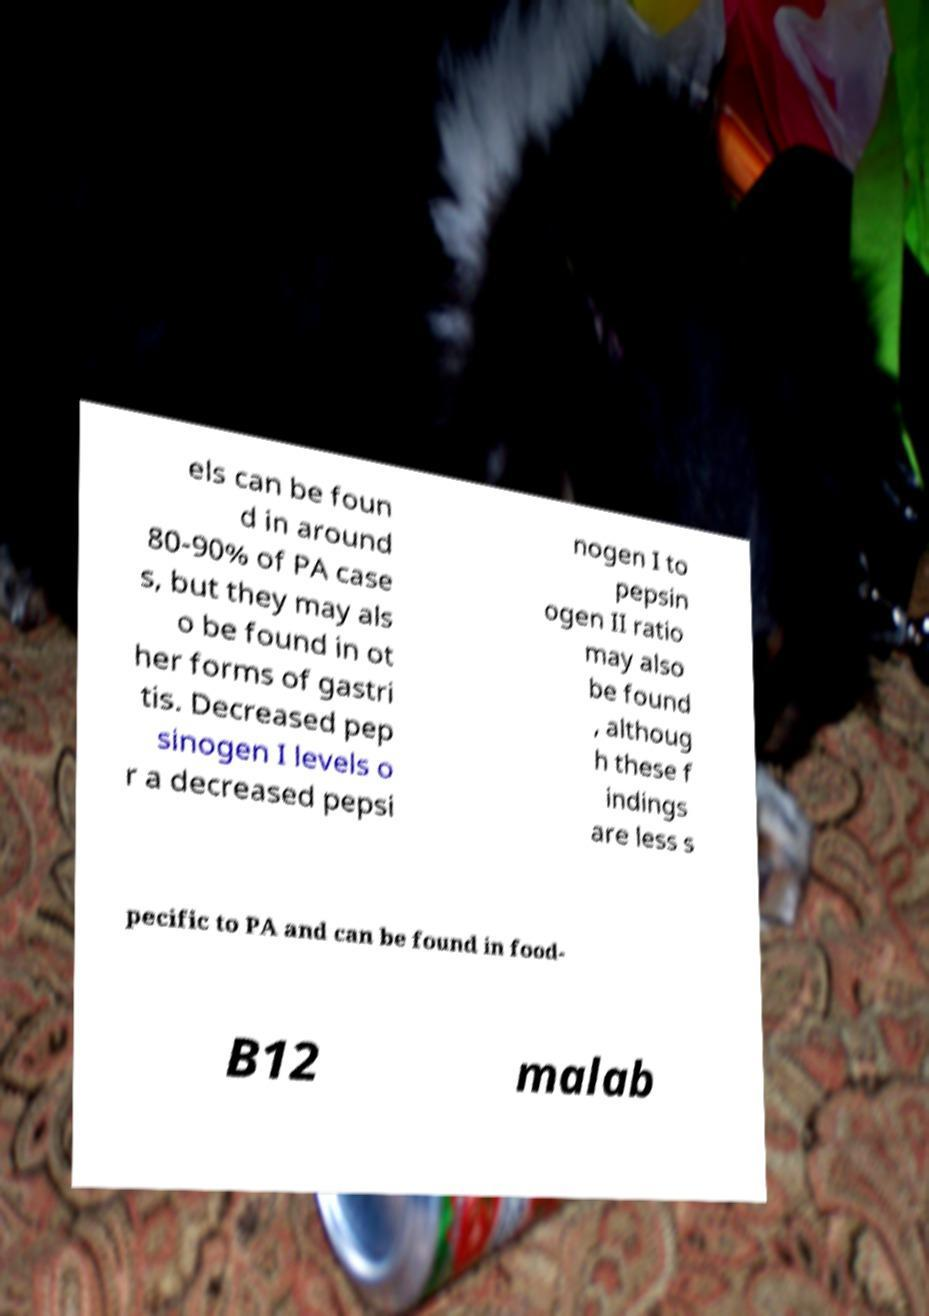Could you assist in decoding the text presented in this image and type it out clearly? els can be foun d in around 80-90% of PA case s, but they may als o be found in ot her forms of gastri tis. Decreased pep sinogen I levels o r a decreased pepsi nogen I to pepsin ogen II ratio may also be found , althoug h these f indings are less s pecific to PA and can be found in food- B12 malab 